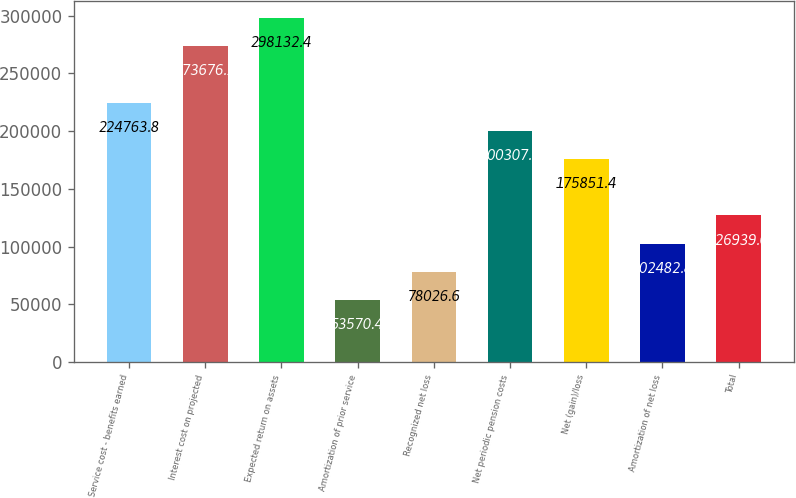Convert chart to OTSL. <chart><loc_0><loc_0><loc_500><loc_500><bar_chart><fcel>Service cost - benefits earned<fcel>Interest cost on projected<fcel>Expected return on assets<fcel>Amortization of prior service<fcel>Recognized net loss<fcel>Net periodic pension costs<fcel>Net (gain)/loss<fcel>Amortization of net loss<fcel>Total<nl><fcel>224764<fcel>273676<fcel>298132<fcel>53570.4<fcel>78026.6<fcel>200308<fcel>175851<fcel>102483<fcel>126939<nl></chart> 